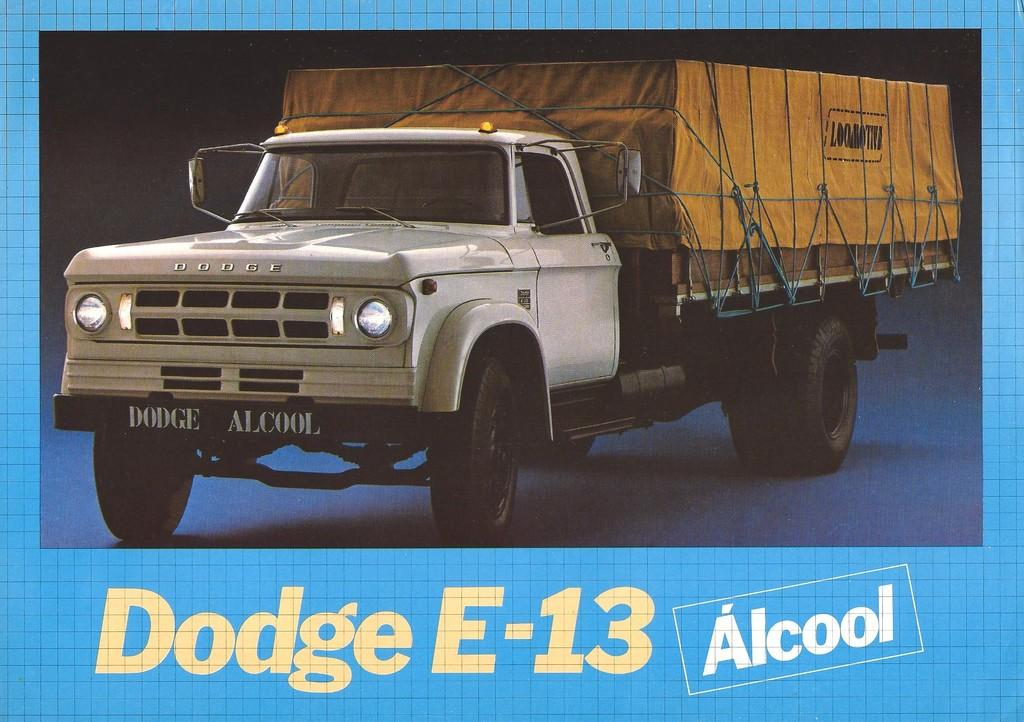What is the main subject of the image? The main subject of the image is a picture of a truck. Is there any text present in the image? Yes, there is text written at the bottom of the image. How many rabbits can be seen playing in the truck in the image? There are no rabbits present in the image; it features a picture of a truck and text at the bottom. 